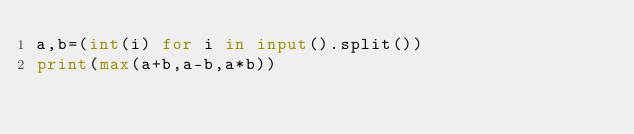<code> <loc_0><loc_0><loc_500><loc_500><_Python_>a,b=(int(i) for i in input().split())
print(max(a+b,a-b,a*b))</code> 